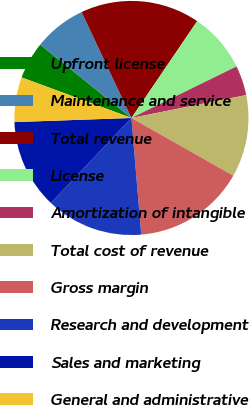Convert chart to OTSL. <chart><loc_0><loc_0><loc_500><loc_500><pie_chart><fcel>Upfront license<fcel>Maintenance and service<fcel>Total revenue<fcel>License<fcel>Amortization of intangible<fcel>Total cost of revenue<fcel>Gross margin<fcel>Research and development<fcel>Sales and marketing<fcel>General and administrative<nl><fcel>5.15%<fcel>7.22%<fcel>16.49%<fcel>8.25%<fcel>4.12%<fcel>11.34%<fcel>15.46%<fcel>13.4%<fcel>12.37%<fcel>6.19%<nl></chart> 